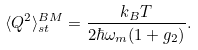<formula> <loc_0><loc_0><loc_500><loc_500>\langle Q ^ { 2 } \rangle _ { s t } ^ { B M } = \frac { k _ { B } T } { 2 \hbar { \omega } _ { m } ( 1 + g _ { 2 } ) } .</formula> 